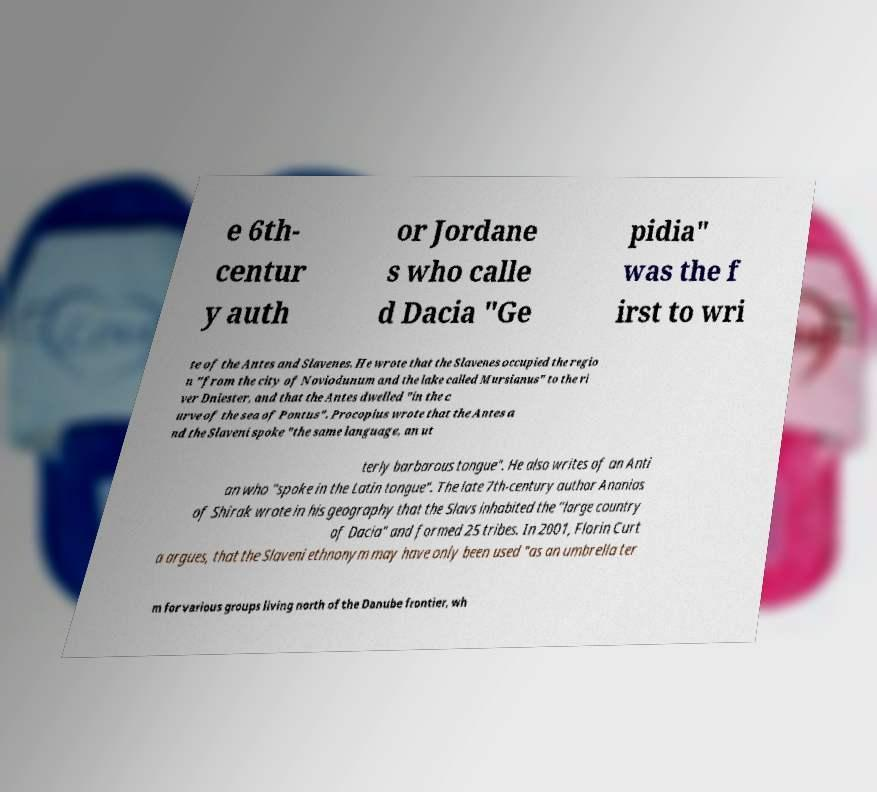Could you assist in decoding the text presented in this image and type it out clearly? e 6th- centur y auth or Jordane s who calle d Dacia "Ge pidia" was the f irst to wri te of the Antes and Slavenes. He wrote that the Slavenes occupied the regio n "from the city of Noviodunum and the lake called Mursianus" to the ri ver Dniester, and that the Antes dwelled "in the c urve of the sea of Pontus". Procopius wrote that the Antes a nd the Slaveni spoke "the same language, an ut terly barbarous tongue". He also writes of an Anti an who "spoke in the Latin tongue". The late 7th-century author Ananias of Shirak wrote in his geography that the Slavs inhabited the "large country of Dacia" and formed 25 tribes. In 2001, Florin Curt a argues, that the Slaveni ethnonym may have only been used "as an umbrella ter m for various groups living north of the Danube frontier, wh 